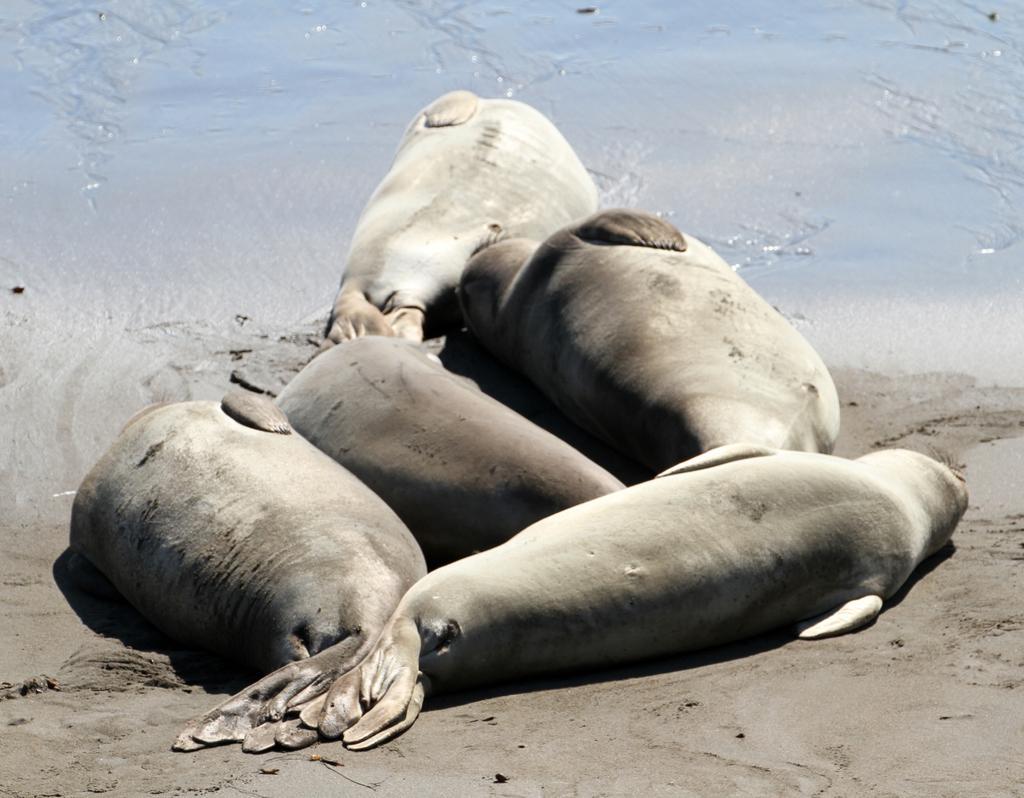Describe this image in one or two sentences. In this picture there are seals in the center of the image and there is water at the top side of the image. 